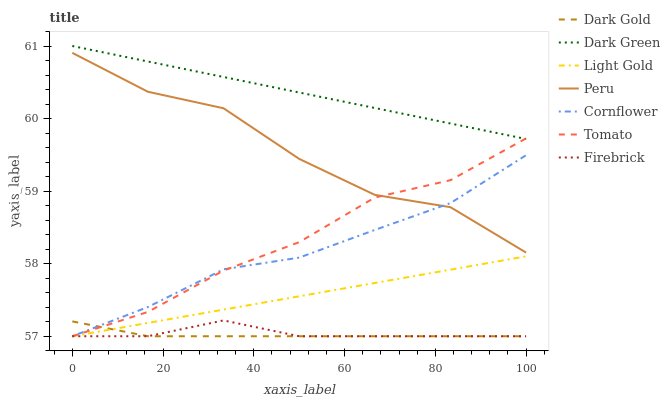Does Dark Gold have the minimum area under the curve?
Answer yes or no. Yes. Does Dark Green have the maximum area under the curve?
Answer yes or no. Yes. Does Cornflower have the minimum area under the curve?
Answer yes or no. No. Does Cornflower have the maximum area under the curve?
Answer yes or no. No. Is Dark Green the smoothest?
Answer yes or no. Yes. Is Peru the roughest?
Answer yes or no. Yes. Is Cornflower the smoothest?
Answer yes or no. No. Is Cornflower the roughest?
Answer yes or no. No. Does Tomato have the lowest value?
Answer yes or no. Yes. Does Peru have the lowest value?
Answer yes or no. No. Does Dark Green have the highest value?
Answer yes or no. Yes. Does Cornflower have the highest value?
Answer yes or no. No. Is Dark Gold less than Peru?
Answer yes or no. Yes. Is Peru greater than Dark Gold?
Answer yes or no. Yes. Does Tomato intersect Dark Green?
Answer yes or no. Yes. Is Tomato less than Dark Green?
Answer yes or no. No. Is Tomato greater than Dark Green?
Answer yes or no. No. Does Dark Gold intersect Peru?
Answer yes or no. No. 